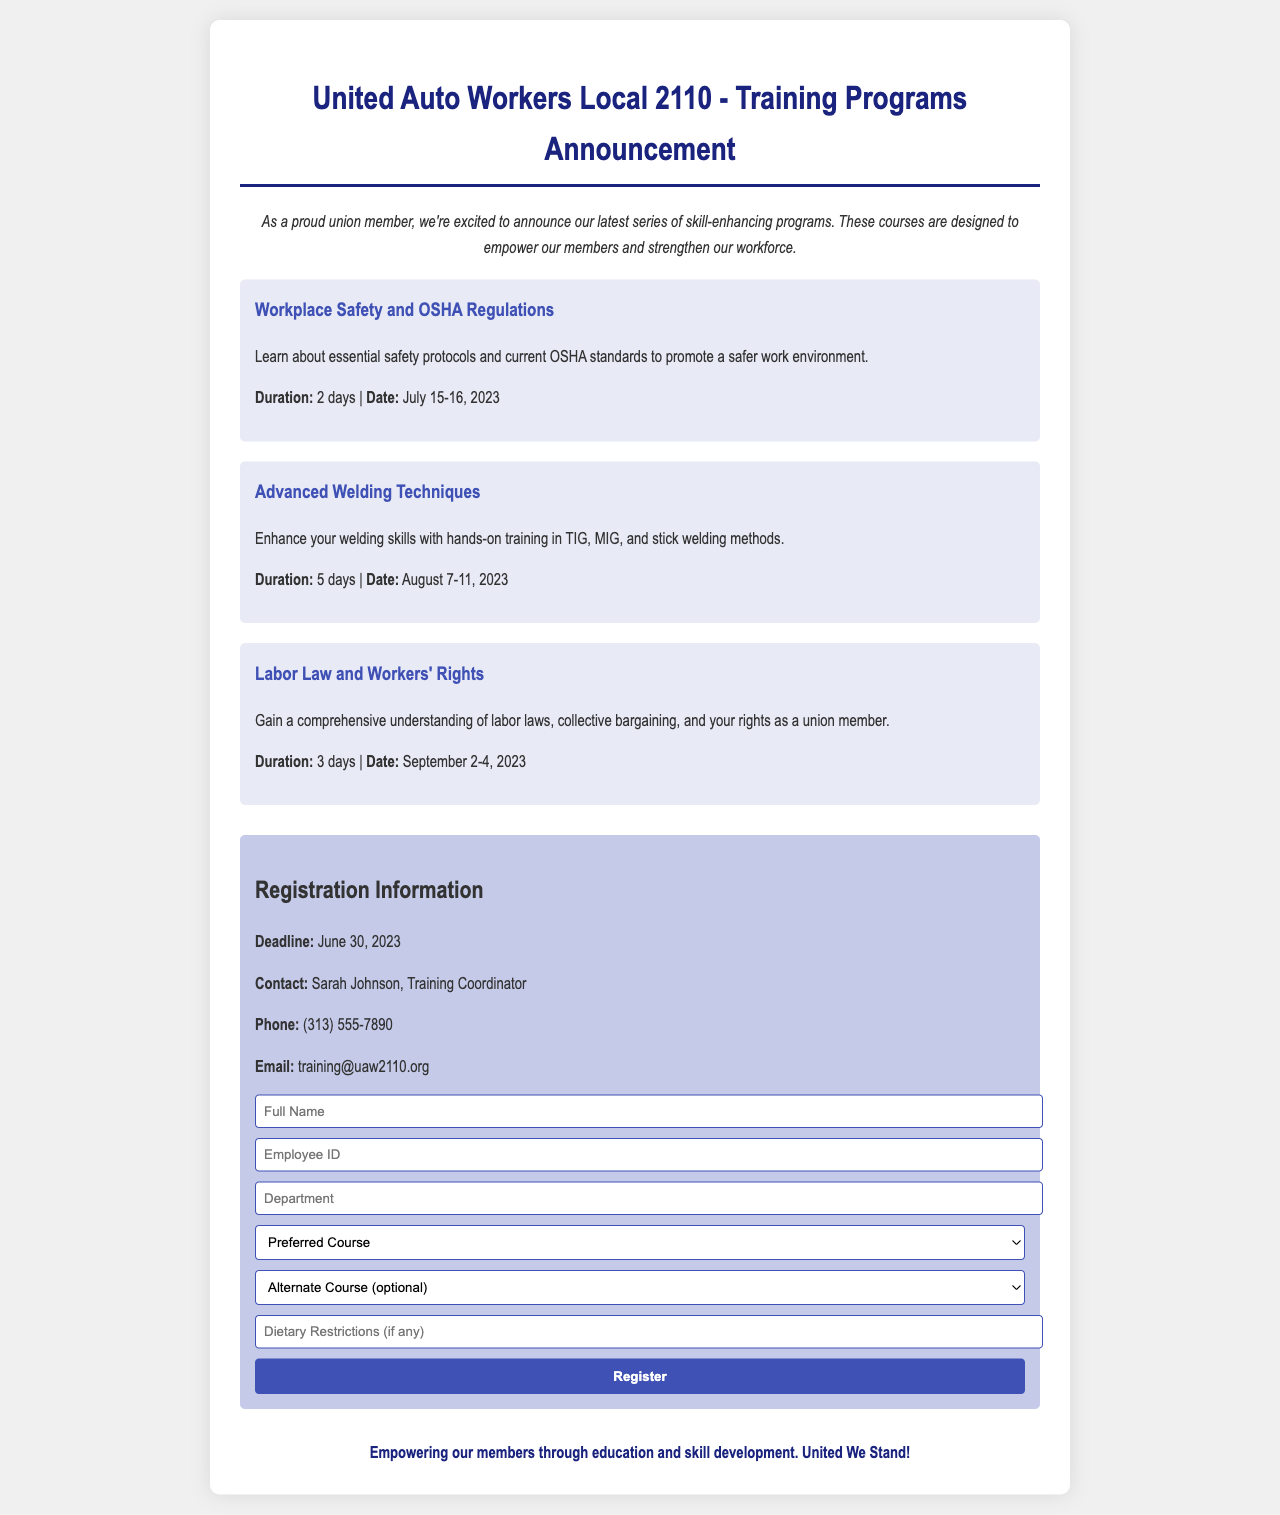what is the title of the announcement? The title of the announcement is indicated at the top of the document.
Answer: United Auto Workers Local 2110 - Training Programs Announcement who is the contact person for registration? The contact person for registration is mentioned in the registration section of the document.
Answer: Sarah Johnson what is the registration deadline? The registration deadline is specified in the registration information.
Answer: June 30, 2023 how long is the Advanced Welding Techniques course? The duration of the Advanced Welding Techniques course is stated in the course description.
Answer: 5 days when does the Labor Law and Workers' Rights course take place? The date of the Labor Law and Workers' Rights course is mentioned in the course details.
Answer: September 2-4, 2023 what is the email address provided for contact? The email address for contact is listed in the registration information.
Answer: training@uaw2110.org what are the dietary restrictions form? The dietary restrictions field is indicated as part of the registration form where participants can provide additional information.
Answer: Dietary Restrictions (if any) who is the training coordinator? The training coordinator is named in the registration information section of the document.
Answer: Sarah Johnson 